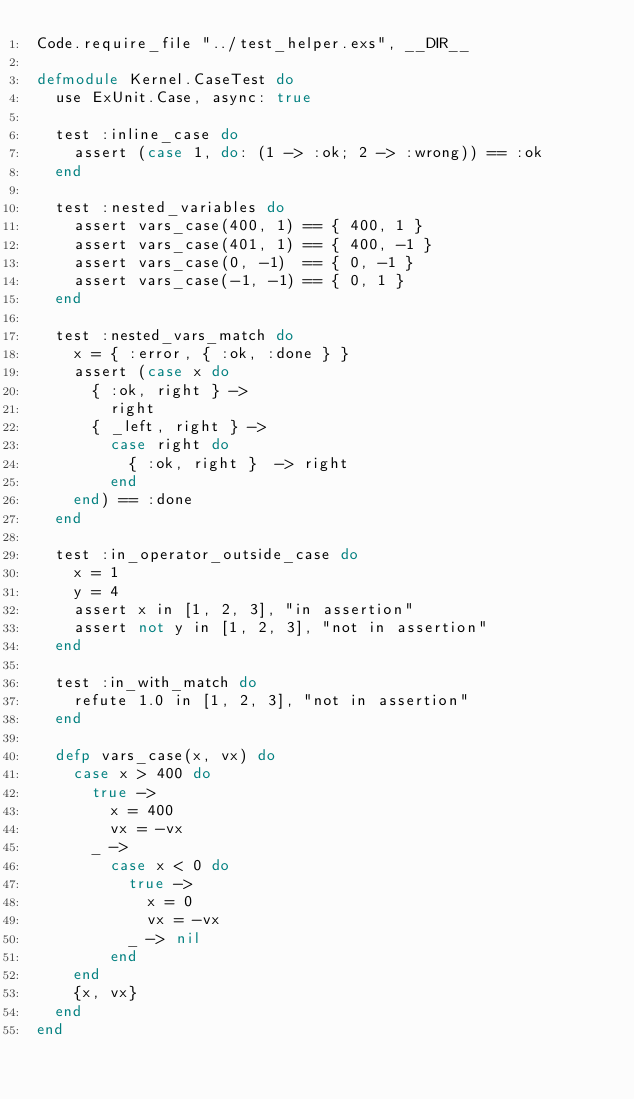<code> <loc_0><loc_0><loc_500><loc_500><_Elixir_>Code.require_file "../test_helper.exs", __DIR__

defmodule Kernel.CaseTest do
  use ExUnit.Case, async: true

  test :inline_case do
    assert (case 1, do: (1 -> :ok; 2 -> :wrong)) == :ok
  end

  test :nested_variables do
    assert vars_case(400, 1) == { 400, 1 }
    assert vars_case(401, 1) == { 400, -1 }
    assert vars_case(0, -1)  == { 0, -1 }
    assert vars_case(-1, -1) == { 0, 1 }
  end

  test :nested_vars_match do
    x = { :error, { :ok, :done } }
    assert (case x do
      { :ok, right } ->
        right
      { _left, right } ->
        case right do
          { :ok, right }  -> right
        end
    end) == :done
  end

  test :in_operator_outside_case do
    x = 1
    y = 4
    assert x in [1, 2, 3], "in assertion"
    assert not y in [1, 2, 3], "not in assertion"
  end

  test :in_with_match do
    refute 1.0 in [1, 2, 3], "not in assertion"
  end

  defp vars_case(x, vx) do
    case x > 400 do
      true ->
        x = 400
        vx = -vx
      _ ->
        case x < 0 do
          true ->
            x = 0
            vx = -vx
          _ -> nil
        end
    end
    {x, vx}
  end
end
</code> 